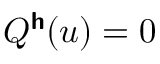<formula> <loc_0><loc_0><loc_500><loc_500>Q ^ { h } ( u ) = 0</formula> 